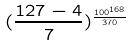Convert formula to latex. <formula><loc_0><loc_0><loc_500><loc_500>( \frac { 1 2 7 - 4 } { 7 } ) ^ { \frac { 1 0 0 ^ { 1 6 8 } } { 3 7 0 } }</formula> 